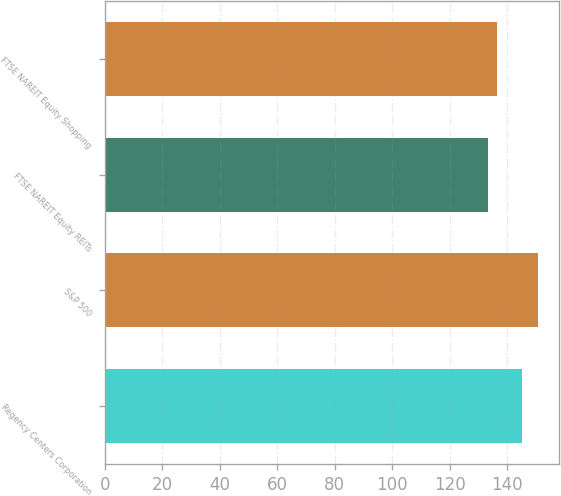Convert chart to OTSL. <chart><loc_0><loc_0><loc_500><loc_500><bar_chart><fcel>Regency Centers Corporation<fcel>S&P 500<fcel>FTSE NAREIT Equity REITs<fcel>FTSE NAREIT Equity Shopping<nl><fcel>145.11<fcel>150.51<fcel>133.35<fcel>136.45<nl></chart> 